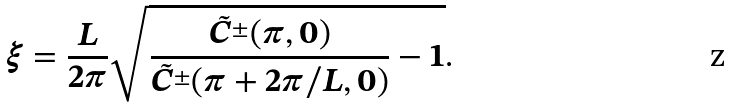<formula> <loc_0><loc_0><loc_500><loc_500>\xi = \frac { L } { 2 \pi } \sqrt { \frac { \tilde { C } ^ { \pm } ( \pi , 0 ) } { \tilde { C } ^ { \pm } ( \pi + 2 \pi / L , 0 ) } - 1 } .</formula> 